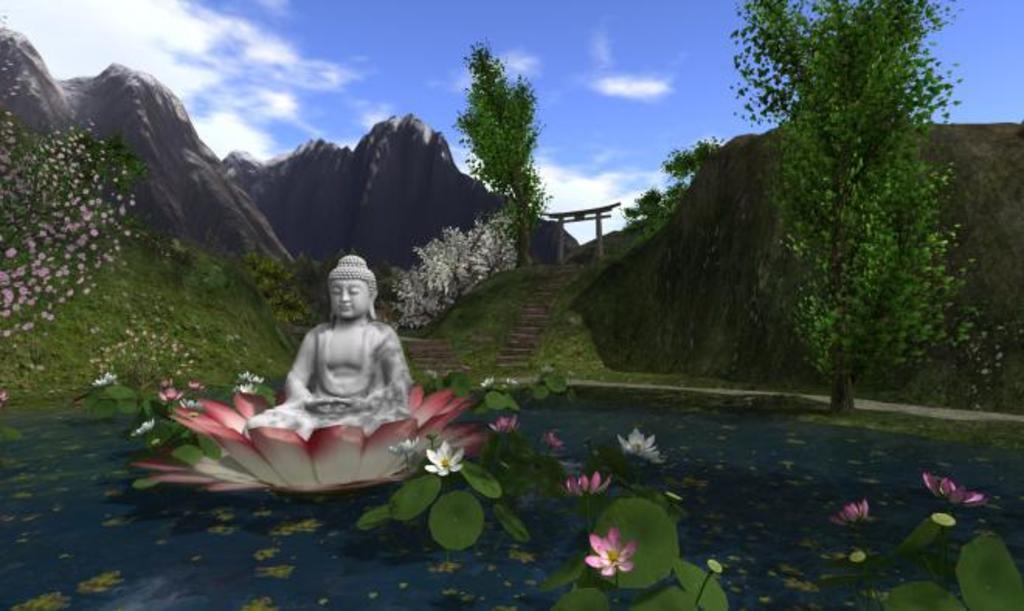Describe this image in one or two sentences. This is an animation image. At the bottom of the image there is water with lotus plants and flowers. In the middle of the water there is a big flower with a statue in it. In the background there are hills with trees and flowers and also there are steps. Behind them there are mountains and at the top of the image there is sky. 